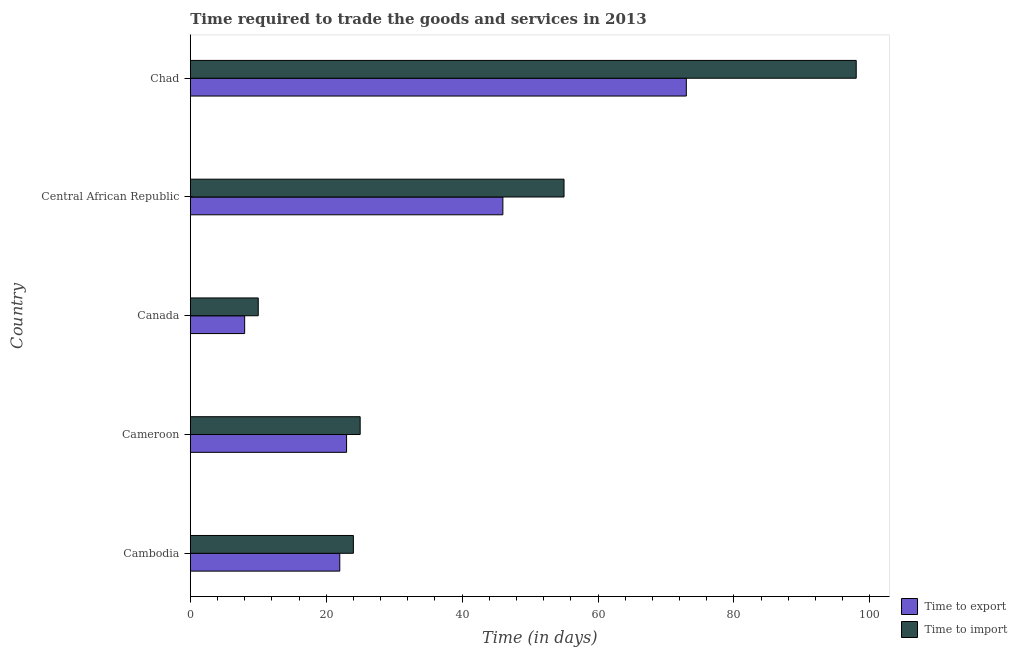How many different coloured bars are there?
Keep it short and to the point. 2. How many groups of bars are there?
Your answer should be very brief. 5. Are the number of bars per tick equal to the number of legend labels?
Keep it short and to the point. Yes. Are the number of bars on each tick of the Y-axis equal?
Provide a short and direct response. Yes. How many bars are there on the 5th tick from the top?
Offer a terse response. 2. How many bars are there on the 2nd tick from the bottom?
Provide a succinct answer. 2. What is the label of the 2nd group of bars from the top?
Ensure brevity in your answer.  Central African Republic. What is the time to import in Chad?
Your response must be concise. 98. Across all countries, what is the minimum time to export?
Your answer should be very brief. 8. In which country was the time to import maximum?
Keep it short and to the point. Chad. What is the total time to export in the graph?
Your answer should be compact. 172. What is the difference between the time to import in Central African Republic and the time to export in Canada?
Your answer should be compact. 47. What is the average time to import per country?
Ensure brevity in your answer.  42.4. What is the difference between the time to export and time to import in Chad?
Your answer should be compact. -25. In how many countries, is the time to export greater than 80 days?
Your answer should be compact. 0. What is the ratio of the time to import in Cambodia to that in Chad?
Give a very brief answer. 0.24. Is the difference between the time to export in Central African Republic and Chad greater than the difference between the time to import in Central African Republic and Chad?
Ensure brevity in your answer.  Yes. What is the difference between the highest and the second highest time to import?
Ensure brevity in your answer.  43. In how many countries, is the time to import greater than the average time to import taken over all countries?
Provide a succinct answer. 2. What does the 2nd bar from the top in Cambodia represents?
Provide a succinct answer. Time to export. What does the 2nd bar from the bottom in Cambodia represents?
Your answer should be compact. Time to import. Are all the bars in the graph horizontal?
Your answer should be very brief. Yes. Does the graph contain grids?
Your answer should be compact. No. Where does the legend appear in the graph?
Make the answer very short. Bottom right. How many legend labels are there?
Offer a terse response. 2. How are the legend labels stacked?
Your response must be concise. Vertical. What is the title of the graph?
Offer a terse response. Time required to trade the goods and services in 2013. Does "Mineral" appear as one of the legend labels in the graph?
Provide a succinct answer. No. What is the label or title of the X-axis?
Your response must be concise. Time (in days). What is the label or title of the Y-axis?
Ensure brevity in your answer.  Country. What is the Time (in days) in Time to export in Cambodia?
Ensure brevity in your answer.  22. What is the Time (in days) in Time to import in Cambodia?
Your answer should be compact. 24. What is the Time (in days) of Time to export in Cameroon?
Make the answer very short. 23. What is the Time (in days) in Time to export in Central African Republic?
Your answer should be very brief. 46. What is the Time (in days) of Time to import in Central African Republic?
Provide a succinct answer. 55. What is the Time (in days) in Time to import in Chad?
Your answer should be very brief. 98. Across all countries, what is the maximum Time (in days) in Time to export?
Offer a very short reply. 73. Across all countries, what is the maximum Time (in days) of Time to import?
Your response must be concise. 98. What is the total Time (in days) of Time to export in the graph?
Ensure brevity in your answer.  172. What is the total Time (in days) of Time to import in the graph?
Offer a very short reply. 212. What is the difference between the Time (in days) of Time to export in Cambodia and that in Cameroon?
Your response must be concise. -1. What is the difference between the Time (in days) of Time to import in Cambodia and that in Cameroon?
Offer a terse response. -1. What is the difference between the Time (in days) in Time to export in Cambodia and that in Central African Republic?
Provide a short and direct response. -24. What is the difference between the Time (in days) of Time to import in Cambodia and that in Central African Republic?
Keep it short and to the point. -31. What is the difference between the Time (in days) in Time to export in Cambodia and that in Chad?
Make the answer very short. -51. What is the difference between the Time (in days) of Time to import in Cambodia and that in Chad?
Provide a succinct answer. -74. What is the difference between the Time (in days) in Time to export in Cameroon and that in Central African Republic?
Offer a terse response. -23. What is the difference between the Time (in days) in Time to import in Cameroon and that in Central African Republic?
Your response must be concise. -30. What is the difference between the Time (in days) of Time to export in Cameroon and that in Chad?
Offer a very short reply. -50. What is the difference between the Time (in days) of Time to import in Cameroon and that in Chad?
Make the answer very short. -73. What is the difference between the Time (in days) of Time to export in Canada and that in Central African Republic?
Give a very brief answer. -38. What is the difference between the Time (in days) of Time to import in Canada and that in Central African Republic?
Offer a terse response. -45. What is the difference between the Time (in days) of Time to export in Canada and that in Chad?
Your answer should be compact. -65. What is the difference between the Time (in days) of Time to import in Canada and that in Chad?
Your answer should be compact. -88. What is the difference between the Time (in days) in Time to import in Central African Republic and that in Chad?
Your response must be concise. -43. What is the difference between the Time (in days) in Time to export in Cambodia and the Time (in days) in Time to import in Cameroon?
Your answer should be very brief. -3. What is the difference between the Time (in days) of Time to export in Cambodia and the Time (in days) of Time to import in Canada?
Offer a very short reply. 12. What is the difference between the Time (in days) of Time to export in Cambodia and the Time (in days) of Time to import in Central African Republic?
Your answer should be compact. -33. What is the difference between the Time (in days) in Time to export in Cambodia and the Time (in days) in Time to import in Chad?
Offer a very short reply. -76. What is the difference between the Time (in days) of Time to export in Cameroon and the Time (in days) of Time to import in Canada?
Your answer should be very brief. 13. What is the difference between the Time (in days) of Time to export in Cameroon and the Time (in days) of Time to import in Central African Republic?
Make the answer very short. -32. What is the difference between the Time (in days) in Time to export in Cameroon and the Time (in days) in Time to import in Chad?
Provide a short and direct response. -75. What is the difference between the Time (in days) in Time to export in Canada and the Time (in days) in Time to import in Central African Republic?
Your answer should be very brief. -47. What is the difference between the Time (in days) of Time to export in Canada and the Time (in days) of Time to import in Chad?
Offer a very short reply. -90. What is the difference between the Time (in days) in Time to export in Central African Republic and the Time (in days) in Time to import in Chad?
Provide a short and direct response. -52. What is the average Time (in days) of Time to export per country?
Offer a very short reply. 34.4. What is the average Time (in days) of Time to import per country?
Offer a terse response. 42.4. What is the difference between the Time (in days) in Time to export and Time (in days) in Time to import in Cambodia?
Your answer should be very brief. -2. What is the difference between the Time (in days) in Time to export and Time (in days) in Time to import in Cameroon?
Offer a very short reply. -2. What is the difference between the Time (in days) of Time to export and Time (in days) of Time to import in Central African Republic?
Offer a terse response. -9. What is the ratio of the Time (in days) in Time to export in Cambodia to that in Cameroon?
Provide a succinct answer. 0.96. What is the ratio of the Time (in days) in Time to import in Cambodia to that in Cameroon?
Keep it short and to the point. 0.96. What is the ratio of the Time (in days) of Time to export in Cambodia to that in Canada?
Your answer should be compact. 2.75. What is the ratio of the Time (in days) of Time to export in Cambodia to that in Central African Republic?
Your answer should be compact. 0.48. What is the ratio of the Time (in days) of Time to import in Cambodia to that in Central African Republic?
Offer a very short reply. 0.44. What is the ratio of the Time (in days) of Time to export in Cambodia to that in Chad?
Provide a short and direct response. 0.3. What is the ratio of the Time (in days) in Time to import in Cambodia to that in Chad?
Your answer should be compact. 0.24. What is the ratio of the Time (in days) of Time to export in Cameroon to that in Canada?
Provide a succinct answer. 2.88. What is the ratio of the Time (in days) of Time to import in Cameroon to that in Central African Republic?
Your response must be concise. 0.45. What is the ratio of the Time (in days) of Time to export in Cameroon to that in Chad?
Offer a terse response. 0.32. What is the ratio of the Time (in days) of Time to import in Cameroon to that in Chad?
Provide a short and direct response. 0.26. What is the ratio of the Time (in days) in Time to export in Canada to that in Central African Republic?
Give a very brief answer. 0.17. What is the ratio of the Time (in days) in Time to import in Canada to that in Central African Republic?
Give a very brief answer. 0.18. What is the ratio of the Time (in days) of Time to export in Canada to that in Chad?
Offer a terse response. 0.11. What is the ratio of the Time (in days) in Time to import in Canada to that in Chad?
Offer a very short reply. 0.1. What is the ratio of the Time (in days) of Time to export in Central African Republic to that in Chad?
Your answer should be very brief. 0.63. What is the ratio of the Time (in days) of Time to import in Central African Republic to that in Chad?
Your answer should be very brief. 0.56. What is the difference between the highest and the second highest Time (in days) of Time to import?
Your answer should be compact. 43. What is the difference between the highest and the lowest Time (in days) of Time to import?
Make the answer very short. 88. 